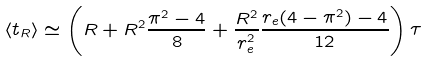Convert formula to latex. <formula><loc_0><loc_0><loc_500><loc_500>\langle t _ { R } \rangle \simeq \left ( R + R ^ { 2 } \frac { \pi ^ { 2 } - 4 } { 8 } + \frac { R ^ { 2 } } { r _ { e } ^ { 2 } } \frac { r _ { e } ( 4 - \pi ^ { 2 } ) - 4 } { 1 2 } \right ) \tau</formula> 